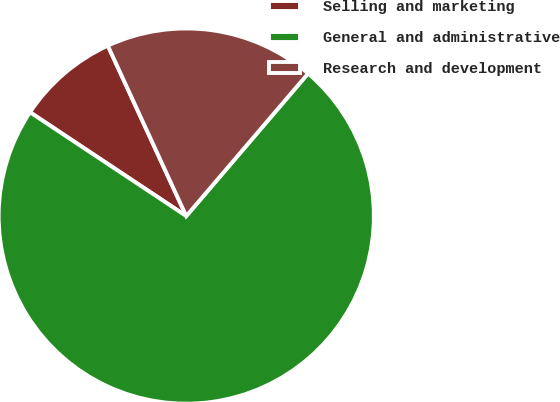Convert chart to OTSL. <chart><loc_0><loc_0><loc_500><loc_500><pie_chart><fcel>Selling and marketing<fcel>General and administrative<fcel>Research and development<nl><fcel>8.8%<fcel>73.08%<fcel>18.12%<nl></chart> 